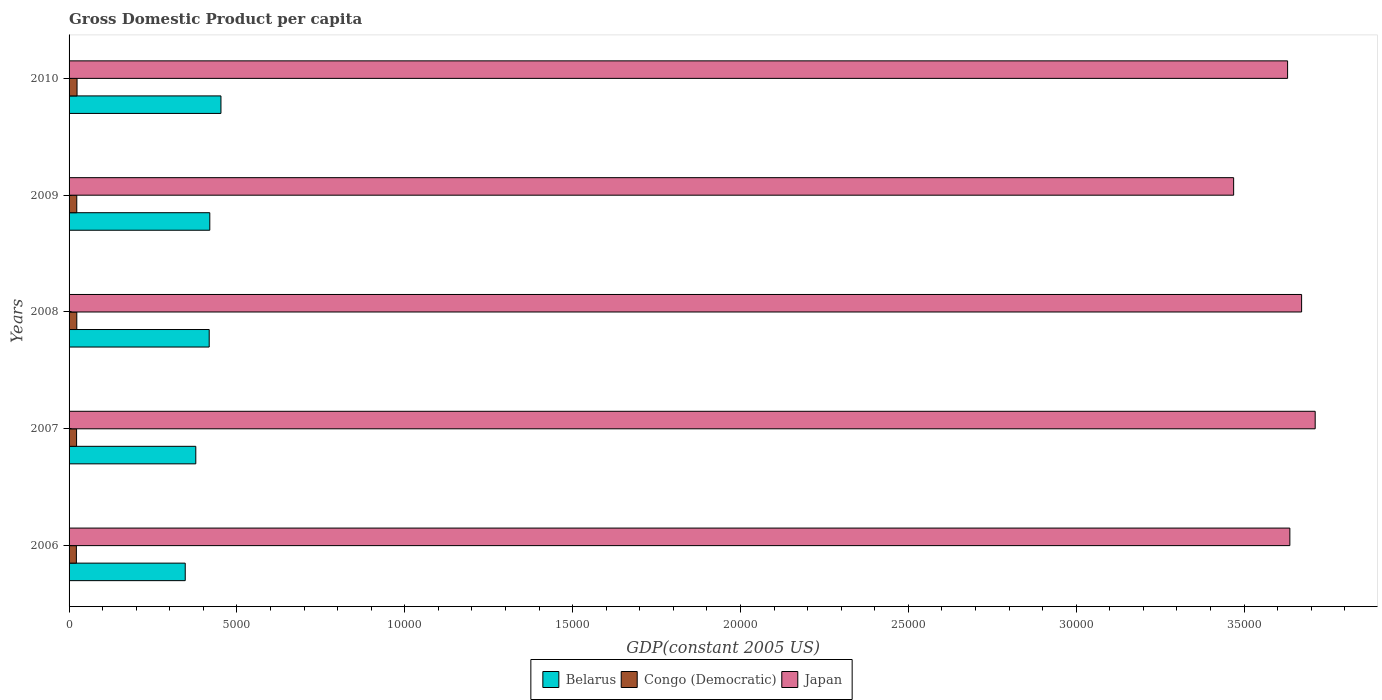How many different coloured bars are there?
Provide a short and direct response. 3. Are the number of bars per tick equal to the number of legend labels?
Your answer should be very brief. Yes. How many bars are there on the 3rd tick from the top?
Make the answer very short. 3. How many bars are there on the 3rd tick from the bottom?
Provide a short and direct response. 3. In how many cases, is the number of bars for a given year not equal to the number of legend labels?
Your answer should be very brief. 0. What is the GDP per capita in Congo (Democratic) in 2008?
Ensure brevity in your answer.  230.12. Across all years, what is the maximum GDP per capita in Japan?
Provide a succinct answer. 3.71e+04. Across all years, what is the minimum GDP per capita in Japan?
Offer a very short reply. 3.47e+04. In which year was the GDP per capita in Belarus maximum?
Make the answer very short. 2010. In which year was the GDP per capita in Congo (Democratic) minimum?
Your answer should be compact. 2006. What is the total GDP per capita in Japan in the graph?
Your response must be concise. 1.81e+05. What is the difference between the GDP per capita in Japan in 2009 and that in 2010?
Offer a very short reply. -1607.23. What is the difference between the GDP per capita in Congo (Democratic) in 2010 and the GDP per capita in Belarus in 2008?
Make the answer very short. -3936.45. What is the average GDP per capita in Congo (Democratic) per year?
Ensure brevity in your answer.  227.63. In the year 2007, what is the difference between the GDP per capita in Japan and GDP per capita in Congo (Democratic)?
Your response must be concise. 3.69e+04. In how many years, is the GDP per capita in Congo (Democratic) greater than 21000 US$?
Offer a very short reply. 0. What is the ratio of the GDP per capita in Japan in 2006 to that in 2010?
Your answer should be very brief. 1. What is the difference between the highest and the second highest GDP per capita in Japan?
Provide a short and direct response. 404.42. What is the difference between the highest and the lowest GDP per capita in Japan?
Offer a terse response. 2429.26. Is the sum of the GDP per capita in Belarus in 2007 and 2008 greater than the maximum GDP per capita in Congo (Democratic) across all years?
Give a very brief answer. Yes. What does the 1st bar from the top in 2009 represents?
Give a very brief answer. Japan. How many bars are there?
Your response must be concise. 15. Are all the bars in the graph horizontal?
Offer a very short reply. Yes. Where does the legend appear in the graph?
Make the answer very short. Bottom center. How are the legend labels stacked?
Offer a terse response. Horizontal. What is the title of the graph?
Provide a succinct answer. Gross Domestic Product per capita. What is the label or title of the X-axis?
Your answer should be very brief. GDP(constant 2005 US). What is the label or title of the Y-axis?
Provide a short and direct response. Years. What is the GDP(constant 2005 US) of Belarus in 2006?
Give a very brief answer. 3460.13. What is the GDP(constant 2005 US) of Congo (Democratic) in 2006?
Give a very brief answer. 217.53. What is the GDP(constant 2005 US) in Japan in 2006?
Make the answer very short. 3.64e+04. What is the GDP(constant 2005 US) in Belarus in 2007?
Provide a succinct answer. 3775. What is the GDP(constant 2005 US) in Congo (Democratic) in 2007?
Offer a terse response. 223.78. What is the GDP(constant 2005 US) in Japan in 2007?
Give a very brief answer. 3.71e+04. What is the GDP(constant 2005 US) in Belarus in 2008?
Your answer should be very brief. 4174.02. What is the GDP(constant 2005 US) of Congo (Democratic) in 2008?
Provide a succinct answer. 230.12. What is the GDP(constant 2005 US) in Japan in 2008?
Provide a short and direct response. 3.67e+04. What is the GDP(constant 2005 US) in Belarus in 2009?
Keep it short and to the point. 4191.61. What is the GDP(constant 2005 US) of Congo (Democratic) in 2009?
Offer a very short reply. 229.14. What is the GDP(constant 2005 US) of Japan in 2009?
Make the answer very short. 3.47e+04. What is the GDP(constant 2005 US) of Belarus in 2010?
Offer a very short reply. 4524.16. What is the GDP(constant 2005 US) in Congo (Democratic) in 2010?
Provide a succinct answer. 237.57. What is the GDP(constant 2005 US) of Japan in 2010?
Offer a terse response. 3.63e+04. Across all years, what is the maximum GDP(constant 2005 US) in Belarus?
Give a very brief answer. 4524.16. Across all years, what is the maximum GDP(constant 2005 US) of Congo (Democratic)?
Give a very brief answer. 237.57. Across all years, what is the maximum GDP(constant 2005 US) of Japan?
Offer a very short reply. 3.71e+04. Across all years, what is the minimum GDP(constant 2005 US) in Belarus?
Provide a succinct answer. 3460.13. Across all years, what is the minimum GDP(constant 2005 US) of Congo (Democratic)?
Your answer should be very brief. 217.53. Across all years, what is the minimum GDP(constant 2005 US) in Japan?
Offer a very short reply. 3.47e+04. What is the total GDP(constant 2005 US) of Belarus in the graph?
Make the answer very short. 2.01e+04. What is the total GDP(constant 2005 US) of Congo (Democratic) in the graph?
Offer a terse response. 1138.15. What is the total GDP(constant 2005 US) of Japan in the graph?
Provide a succinct answer. 1.81e+05. What is the difference between the GDP(constant 2005 US) of Belarus in 2006 and that in 2007?
Offer a terse response. -314.87. What is the difference between the GDP(constant 2005 US) in Congo (Democratic) in 2006 and that in 2007?
Provide a short and direct response. -6.25. What is the difference between the GDP(constant 2005 US) of Japan in 2006 and that in 2007?
Ensure brevity in your answer.  -754.49. What is the difference between the GDP(constant 2005 US) of Belarus in 2006 and that in 2008?
Offer a terse response. -713.89. What is the difference between the GDP(constant 2005 US) of Congo (Democratic) in 2006 and that in 2008?
Your answer should be very brief. -12.58. What is the difference between the GDP(constant 2005 US) of Japan in 2006 and that in 2008?
Make the answer very short. -350.07. What is the difference between the GDP(constant 2005 US) of Belarus in 2006 and that in 2009?
Give a very brief answer. -731.47. What is the difference between the GDP(constant 2005 US) of Congo (Democratic) in 2006 and that in 2009?
Provide a short and direct response. -11.61. What is the difference between the GDP(constant 2005 US) in Japan in 2006 and that in 2009?
Your answer should be compact. 1674.77. What is the difference between the GDP(constant 2005 US) of Belarus in 2006 and that in 2010?
Your response must be concise. -1064.03. What is the difference between the GDP(constant 2005 US) in Congo (Democratic) in 2006 and that in 2010?
Provide a short and direct response. -20.04. What is the difference between the GDP(constant 2005 US) of Japan in 2006 and that in 2010?
Ensure brevity in your answer.  67.54. What is the difference between the GDP(constant 2005 US) of Belarus in 2007 and that in 2008?
Provide a succinct answer. -399.02. What is the difference between the GDP(constant 2005 US) of Congo (Democratic) in 2007 and that in 2008?
Make the answer very short. -6.34. What is the difference between the GDP(constant 2005 US) of Japan in 2007 and that in 2008?
Your response must be concise. 404.42. What is the difference between the GDP(constant 2005 US) of Belarus in 2007 and that in 2009?
Provide a succinct answer. -416.61. What is the difference between the GDP(constant 2005 US) in Congo (Democratic) in 2007 and that in 2009?
Your answer should be compact. -5.36. What is the difference between the GDP(constant 2005 US) of Japan in 2007 and that in 2009?
Offer a terse response. 2429.26. What is the difference between the GDP(constant 2005 US) in Belarus in 2007 and that in 2010?
Your answer should be compact. -749.16. What is the difference between the GDP(constant 2005 US) of Congo (Democratic) in 2007 and that in 2010?
Ensure brevity in your answer.  -13.79. What is the difference between the GDP(constant 2005 US) in Japan in 2007 and that in 2010?
Make the answer very short. 822.03. What is the difference between the GDP(constant 2005 US) in Belarus in 2008 and that in 2009?
Provide a short and direct response. -17.59. What is the difference between the GDP(constant 2005 US) in Congo (Democratic) in 2008 and that in 2009?
Offer a very short reply. 0.98. What is the difference between the GDP(constant 2005 US) in Japan in 2008 and that in 2009?
Offer a very short reply. 2024.84. What is the difference between the GDP(constant 2005 US) of Belarus in 2008 and that in 2010?
Provide a succinct answer. -350.14. What is the difference between the GDP(constant 2005 US) in Congo (Democratic) in 2008 and that in 2010?
Offer a terse response. -7.45. What is the difference between the GDP(constant 2005 US) in Japan in 2008 and that in 2010?
Your answer should be compact. 417.61. What is the difference between the GDP(constant 2005 US) in Belarus in 2009 and that in 2010?
Your response must be concise. -332.55. What is the difference between the GDP(constant 2005 US) of Congo (Democratic) in 2009 and that in 2010?
Your answer should be compact. -8.43. What is the difference between the GDP(constant 2005 US) of Japan in 2009 and that in 2010?
Offer a terse response. -1607.23. What is the difference between the GDP(constant 2005 US) in Belarus in 2006 and the GDP(constant 2005 US) in Congo (Democratic) in 2007?
Offer a terse response. 3236.35. What is the difference between the GDP(constant 2005 US) in Belarus in 2006 and the GDP(constant 2005 US) in Japan in 2007?
Your response must be concise. -3.37e+04. What is the difference between the GDP(constant 2005 US) in Congo (Democratic) in 2006 and the GDP(constant 2005 US) in Japan in 2007?
Keep it short and to the point. -3.69e+04. What is the difference between the GDP(constant 2005 US) in Belarus in 2006 and the GDP(constant 2005 US) in Congo (Democratic) in 2008?
Keep it short and to the point. 3230.01. What is the difference between the GDP(constant 2005 US) in Belarus in 2006 and the GDP(constant 2005 US) in Japan in 2008?
Your answer should be very brief. -3.33e+04. What is the difference between the GDP(constant 2005 US) in Congo (Democratic) in 2006 and the GDP(constant 2005 US) in Japan in 2008?
Offer a terse response. -3.65e+04. What is the difference between the GDP(constant 2005 US) in Belarus in 2006 and the GDP(constant 2005 US) in Congo (Democratic) in 2009?
Offer a terse response. 3230.99. What is the difference between the GDP(constant 2005 US) in Belarus in 2006 and the GDP(constant 2005 US) in Japan in 2009?
Give a very brief answer. -3.12e+04. What is the difference between the GDP(constant 2005 US) in Congo (Democratic) in 2006 and the GDP(constant 2005 US) in Japan in 2009?
Give a very brief answer. -3.45e+04. What is the difference between the GDP(constant 2005 US) in Belarus in 2006 and the GDP(constant 2005 US) in Congo (Democratic) in 2010?
Keep it short and to the point. 3222.56. What is the difference between the GDP(constant 2005 US) of Belarus in 2006 and the GDP(constant 2005 US) of Japan in 2010?
Make the answer very short. -3.28e+04. What is the difference between the GDP(constant 2005 US) of Congo (Democratic) in 2006 and the GDP(constant 2005 US) of Japan in 2010?
Offer a terse response. -3.61e+04. What is the difference between the GDP(constant 2005 US) of Belarus in 2007 and the GDP(constant 2005 US) of Congo (Democratic) in 2008?
Keep it short and to the point. 3544.88. What is the difference between the GDP(constant 2005 US) in Belarus in 2007 and the GDP(constant 2005 US) in Japan in 2008?
Provide a succinct answer. -3.29e+04. What is the difference between the GDP(constant 2005 US) of Congo (Democratic) in 2007 and the GDP(constant 2005 US) of Japan in 2008?
Provide a short and direct response. -3.65e+04. What is the difference between the GDP(constant 2005 US) in Belarus in 2007 and the GDP(constant 2005 US) in Congo (Democratic) in 2009?
Ensure brevity in your answer.  3545.86. What is the difference between the GDP(constant 2005 US) of Belarus in 2007 and the GDP(constant 2005 US) of Japan in 2009?
Your answer should be compact. -3.09e+04. What is the difference between the GDP(constant 2005 US) of Congo (Democratic) in 2007 and the GDP(constant 2005 US) of Japan in 2009?
Your answer should be compact. -3.45e+04. What is the difference between the GDP(constant 2005 US) in Belarus in 2007 and the GDP(constant 2005 US) in Congo (Democratic) in 2010?
Ensure brevity in your answer.  3537.43. What is the difference between the GDP(constant 2005 US) of Belarus in 2007 and the GDP(constant 2005 US) of Japan in 2010?
Give a very brief answer. -3.25e+04. What is the difference between the GDP(constant 2005 US) in Congo (Democratic) in 2007 and the GDP(constant 2005 US) in Japan in 2010?
Your answer should be compact. -3.61e+04. What is the difference between the GDP(constant 2005 US) in Belarus in 2008 and the GDP(constant 2005 US) in Congo (Democratic) in 2009?
Your response must be concise. 3944.88. What is the difference between the GDP(constant 2005 US) of Belarus in 2008 and the GDP(constant 2005 US) of Japan in 2009?
Provide a succinct answer. -3.05e+04. What is the difference between the GDP(constant 2005 US) of Congo (Democratic) in 2008 and the GDP(constant 2005 US) of Japan in 2009?
Offer a terse response. -3.45e+04. What is the difference between the GDP(constant 2005 US) in Belarus in 2008 and the GDP(constant 2005 US) in Congo (Democratic) in 2010?
Your answer should be compact. 3936.45. What is the difference between the GDP(constant 2005 US) of Belarus in 2008 and the GDP(constant 2005 US) of Japan in 2010?
Your response must be concise. -3.21e+04. What is the difference between the GDP(constant 2005 US) of Congo (Democratic) in 2008 and the GDP(constant 2005 US) of Japan in 2010?
Ensure brevity in your answer.  -3.61e+04. What is the difference between the GDP(constant 2005 US) in Belarus in 2009 and the GDP(constant 2005 US) in Congo (Democratic) in 2010?
Provide a short and direct response. 3954.03. What is the difference between the GDP(constant 2005 US) of Belarus in 2009 and the GDP(constant 2005 US) of Japan in 2010?
Your answer should be very brief. -3.21e+04. What is the difference between the GDP(constant 2005 US) of Congo (Democratic) in 2009 and the GDP(constant 2005 US) of Japan in 2010?
Offer a terse response. -3.61e+04. What is the average GDP(constant 2005 US) of Belarus per year?
Your answer should be compact. 4024.98. What is the average GDP(constant 2005 US) in Congo (Democratic) per year?
Give a very brief answer. 227.63. What is the average GDP(constant 2005 US) in Japan per year?
Your response must be concise. 3.62e+04. In the year 2006, what is the difference between the GDP(constant 2005 US) of Belarus and GDP(constant 2005 US) of Congo (Democratic)?
Offer a terse response. 3242.6. In the year 2006, what is the difference between the GDP(constant 2005 US) of Belarus and GDP(constant 2005 US) of Japan?
Offer a terse response. -3.29e+04. In the year 2006, what is the difference between the GDP(constant 2005 US) in Congo (Democratic) and GDP(constant 2005 US) in Japan?
Your answer should be compact. -3.61e+04. In the year 2007, what is the difference between the GDP(constant 2005 US) of Belarus and GDP(constant 2005 US) of Congo (Democratic)?
Give a very brief answer. 3551.22. In the year 2007, what is the difference between the GDP(constant 2005 US) in Belarus and GDP(constant 2005 US) in Japan?
Provide a succinct answer. -3.33e+04. In the year 2007, what is the difference between the GDP(constant 2005 US) in Congo (Democratic) and GDP(constant 2005 US) in Japan?
Offer a very short reply. -3.69e+04. In the year 2008, what is the difference between the GDP(constant 2005 US) of Belarus and GDP(constant 2005 US) of Congo (Democratic)?
Give a very brief answer. 3943.9. In the year 2008, what is the difference between the GDP(constant 2005 US) in Belarus and GDP(constant 2005 US) in Japan?
Keep it short and to the point. -3.25e+04. In the year 2008, what is the difference between the GDP(constant 2005 US) in Congo (Democratic) and GDP(constant 2005 US) in Japan?
Ensure brevity in your answer.  -3.65e+04. In the year 2009, what is the difference between the GDP(constant 2005 US) of Belarus and GDP(constant 2005 US) of Congo (Democratic)?
Give a very brief answer. 3962.46. In the year 2009, what is the difference between the GDP(constant 2005 US) in Belarus and GDP(constant 2005 US) in Japan?
Your response must be concise. -3.05e+04. In the year 2009, what is the difference between the GDP(constant 2005 US) in Congo (Democratic) and GDP(constant 2005 US) in Japan?
Provide a short and direct response. -3.45e+04. In the year 2010, what is the difference between the GDP(constant 2005 US) of Belarus and GDP(constant 2005 US) of Congo (Democratic)?
Your answer should be compact. 4286.59. In the year 2010, what is the difference between the GDP(constant 2005 US) in Belarus and GDP(constant 2005 US) in Japan?
Offer a very short reply. -3.18e+04. In the year 2010, what is the difference between the GDP(constant 2005 US) of Congo (Democratic) and GDP(constant 2005 US) of Japan?
Offer a very short reply. -3.61e+04. What is the ratio of the GDP(constant 2005 US) of Belarus in 2006 to that in 2007?
Keep it short and to the point. 0.92. What is the ratio of the GDP(constant 2005 US) of Congo (Democratic) in 2006 to that in 2007?
Ensure brevity in your answer.  0.97. What is the ratio of the GDP(constant 2005 US) in Japan in 2006 to that in 2007?
Your answer should be very brief. 0.98. What is the ratio of the GDP(constant 2005 US) of Belarus in 2006 to that in 2008?
Make the answer very short. 0.83. What is the ratio of the GDP(constant 2005 US) of Congo (Democratic) in 2006 to that in 2008?
Your response must be concise. 0.95. What is the ratio of the GDP(constant 2005 US) of Belarus in 2006 to that in 2009?
Keep it short and to the point. 0.83. What is the ratio of the GDP(constant 2005 US) of Congo (Democratic) in 2006 to that in 2009?
Make the answer very short. 0.95. What is the ratio of the GDP(constant 2005 US) in Japan in 2006 to that in 2009?
Your response must be concise. 1.05. What is the ratio of the GDP(constant 2005 US) in Belarus in 2006 to that in 2010?
Offer a very short reply. 0.76. What is the ratio of the GDP(constant 2005 US) in Congo (Democratic) in 2006 to that in 2010?
Ensure brevity in your answer.  0.92. What is the ratio of the GDP(constant 2005 US) in Japan in 2006 to that in 2010?
Provide a succinct answer. 1. What is the ratio of the GDP(constant 2005 US) in Belarus in 2007 to that in 2008?
Keep it short and to the point. 0.9. What is the ratio of the GDP(constant 2005 US) of Congo (Democratic) in 2007 to that in 2008?
Ensure brevity in your answer.  0.97. What is the ratio of the GDP(constant 2005 US) in Japan in 2007 to that in 2008?
Your response must be concise. 1.01. What is the ratio of the GDP(constant 2005 US) in Belarus in 2007 to that in 2009?
Keep it short and to the point. 0.9. What is the ratio of the GDP(constant 2005 US) in Congo (Democratic) in 2007 to that in 2009?
Offer a terse response. 0.98. What is the ratio of the GDP(constant 2005 US) of Japan in 2007 to that in 2009?
Your answer should be compact. 1.07. What is the ratio of the GDP(constant 2005 US) in Belarus in 2007 to that in 2010?
Your response must be concise. 0.83. What is the ratio of the GDP(constant 2005 US) of Congo (Democratic) in 2007 to that in 2010?
Give a very brief answer. 0.94. What is the ratio of the GDP(constant 2005 US) of Japan in 2007 to that in 2010?
Give a very brief answer. 1.02. What is the ratio of the GDP(constant 2005 US) in Belarus in 2008 to that in 2009?
Provide a succinct answer. 1. What is the ratio of the GDP(constant 2005 US) of Japan in 2008 to that in 2009?
Offer a terse response. 1.06. What is the ratio of the GDP(constant 2005 US) in Belarus in 2008 to that in 2010?
Give a very brief answer. 0.92. What is the ratio of the GDP(constant 2005 US) of Congo (Democratic) in 2008 to that in 2010?
Your answer should be very brief. 0.97. What is the ratio of the GDP(constant 2005 US) in Japan in 2008 to that in 2010?
Give a very brief answer. 1.01. What is the ratio of the GDP(constant 2005 US) in Belarus in 2009 to that in 2010?
Your answer should be compact. 0.93. What is the ratio of the GDP(constant 2005 US) in Congo (Democratic) in 2009 to that in 2010?
Provide a succinct answer. 0.96. What is the ratio of the GDP(constant 2005 US) in Japan in 2009 to that in 2010?
Keep it short and to the point. 0.96. What is the difference between the highest and the second highest GDP(constant 2005 US) in Belarus?
Provide a succinct answer. 332.55. What is the difference between the highest and the second highest GDP(constant 2005 US) in Congo (Democratic)?
Keep it short and to the point. 7.45. What is the difference between the highest and the second highest GDP(constant 2005 US) in Japan?
Your answer should be very brief. 404.42. What is the difference between the highest and the lowest GDP(constant 2005 US) in Belarus?
Provide a short and direct response. 1064.03. What is the difference between the highest and the lowest GDP(constant 2005 US) in Congo (Democratic)?
Ensure brevity in your answer.  20.04. What is the difference between the highest and the lowest GDP(constant 2005 US) in Japan?
Provide a short and direct response. 2429.26. 